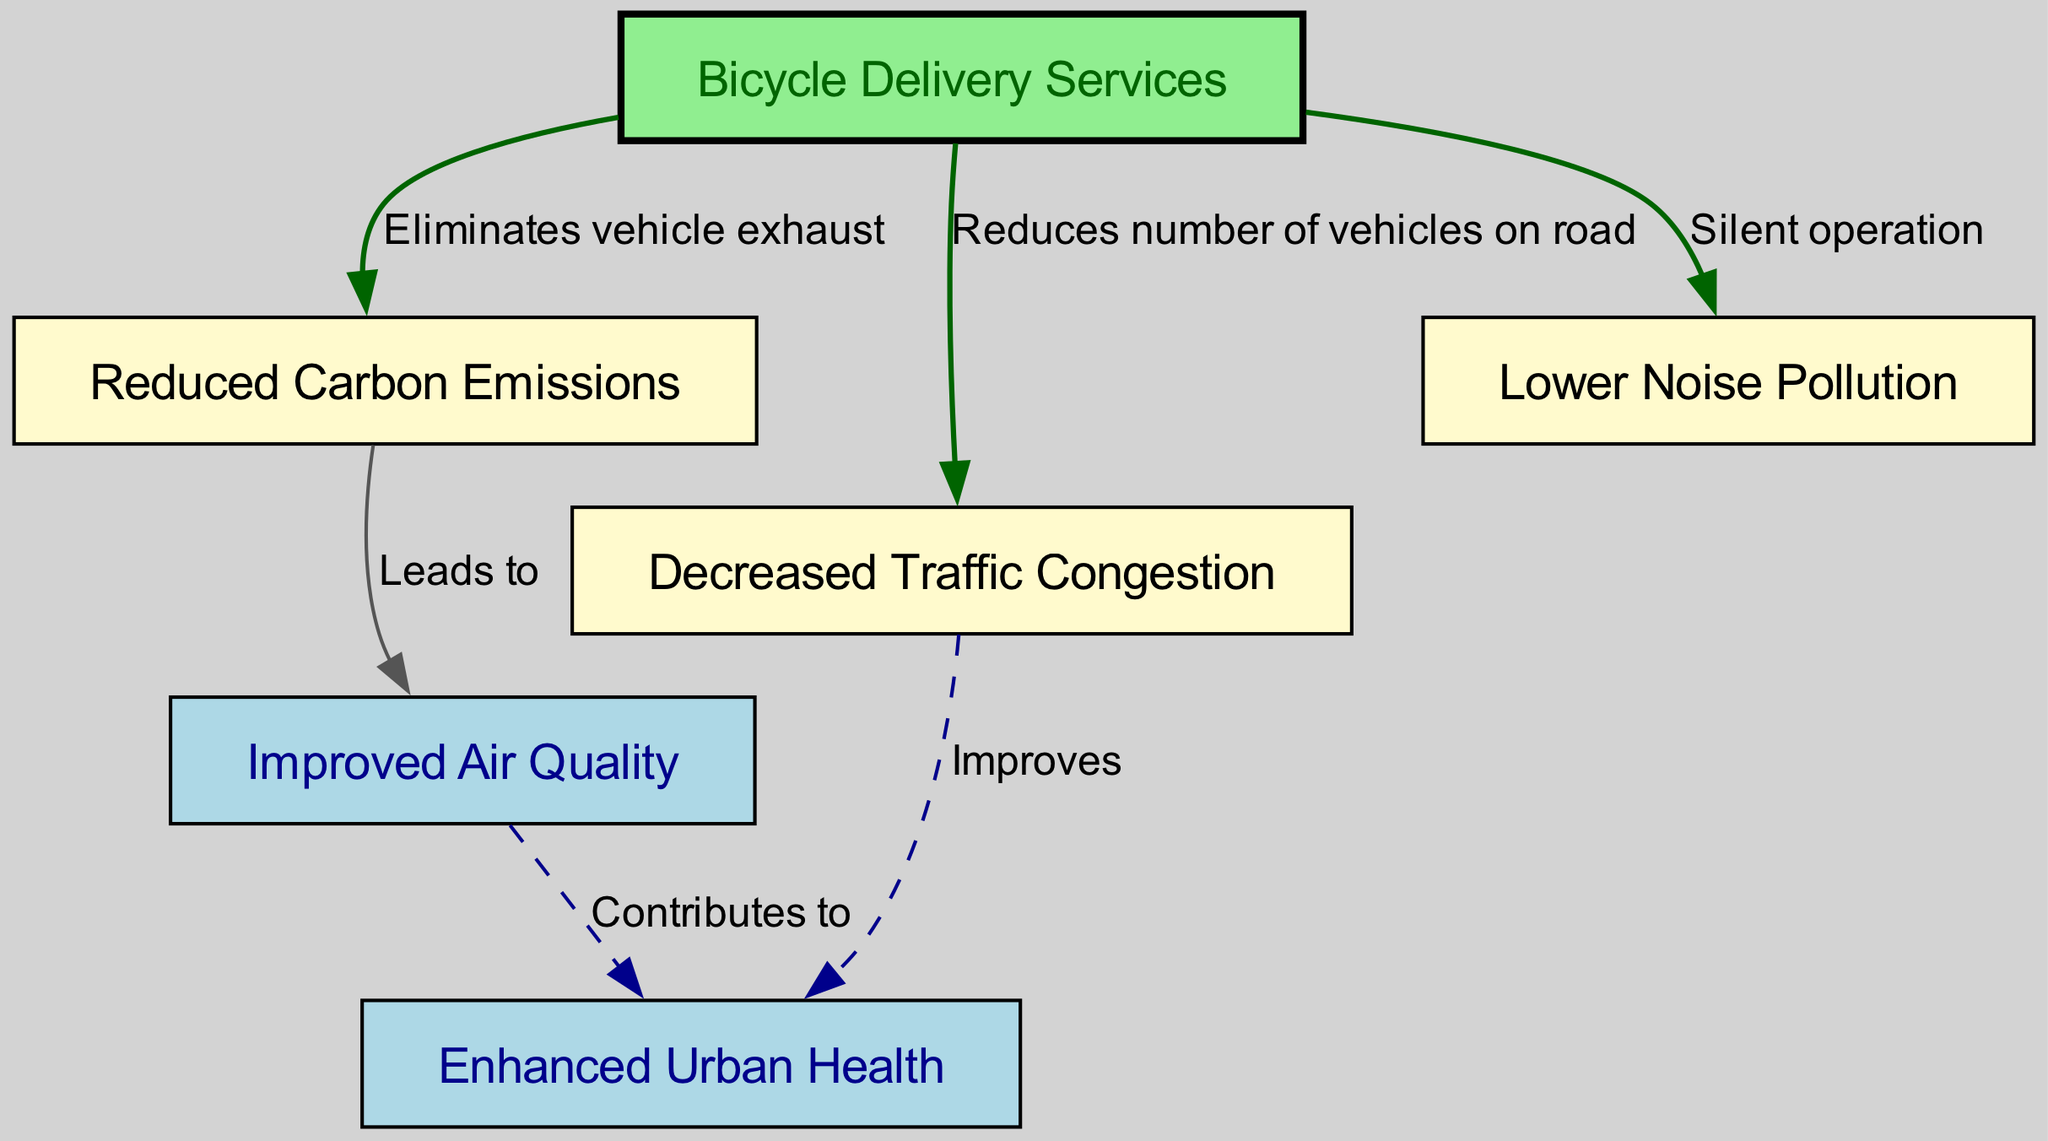What is the central node in the diagram? The central node is "Bicycle Delivery Services" as it is the starting point from which all other benefits are connected.
Answer: Bicycle Delivery Services How many nodes are in the diagram? The diagram lists a total of six nodes that represent different elements of the bicycle delivery services' environmental benefits.
Answer: 6 What relationship does "bicycleDelivery" have with "carbonEmissions"? The relationship is labeled as "Eliminates vehicle exhaust," indicating that bicycle delivery services help to reduce carbon emissions by not producing vehicle exhaust.
Answer: Eliminates vehicle exhaust Which node indicates a direct effect on urban health? The diagram shows "Enhanced Urban Health" as a node that is influenced by both "Improved Air Quality" and "Decreased Traffic Congestion," making it the node that indicates a direct effect.
Answer: Enhanced Urban Health What does "trafficCongestion" improve according to the diagram? The diagram states that "trafficCongestion" improves "urbanHealth," meaning that reduced congestion contributes positively to urban health outcomes.
Answer: urbanHealth Which node is connected to "Improved Air Quality"? The node connected to "Improved Air Quality" is "Reduced Carbon Emissions," as indicated by the relationship "Leads to," suggesting that improved air quality results from lower carbon emissions.
Answer: Reduced Carbon Emissions What is the color of the "bicycleDelivery" node? The "bicycleDelivery" node is colored light green, which makes it stand out visually compared to the other nodes in the diagram.
Answer: light green How does "noiseReduction" relate to bicycle delivery services? The relationship is described as "Silent operation," meaning bicycle delivery services contribute to lower noise pollution due to their quiet functioning compared to motorized transport.
Answer: Silent operation What does "Reduced Carbon Emissions" contribute to? "Reduced Carbon Emissions" contributes to "Improved Air Quality," indicating that cutting down emissions directly leads to better air quality in the environment.
Answer: Improved Air Quality 